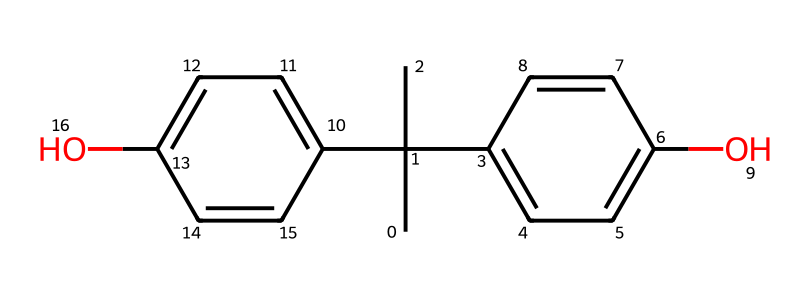What is the molecular formula of bisphenol A? The SMILES representation indicates two hydroxy groups (O) and many carbon (C) and hydrogen (H) atoms. Counting all the atoms leads to a molecular formula of C15H16O2.
Answer: C15H16O2 How many carbon atoms are present in this molecule? By analyzing the SMILES, there are 15 carbon atoms represented in the structure. Each 'C' corresponds to one carbon atom and counting them gives the total.
Answer: 15 What type of functional groups are present in bisphenol A? The SMILES shows two hydroxyl (OH) groups as indicated by the presence of "O" connected to carbon atoms. Thus, the functional groups are identified as hydroxyl groups.
Answer: hydroxyl groups How many cyclic structures can be found in bisphenol A? The structure contains two cyclohexene (C6) rings, as inferred from the presence of the alternating double bonds and enclosed 'C' atoms in the SMILES representation.
Answer: 2 Which feature of bisphenol A relates to its estrogenic activity? The aromatic rings contribute to bisphenol A's similarity to estrogen by allowing it to bind to estrogen receptors; this is inferred from the presence of these rings in the chemical structure.
Answer: aromatic rings What is the total number of oxygen atoms in bisphenol A? In the SMILES representation, there are two instances of "O", which indicates that there are two oxygen atoms in the molecule.
Answer: 2 